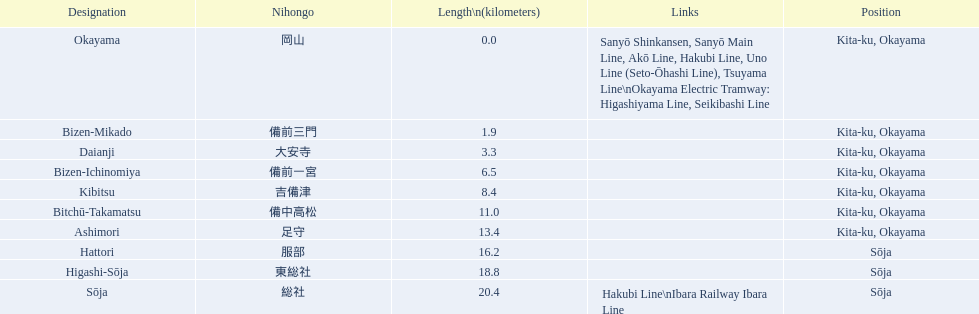Name only the stations that have connections to other lines. Okayama, Sōja. 